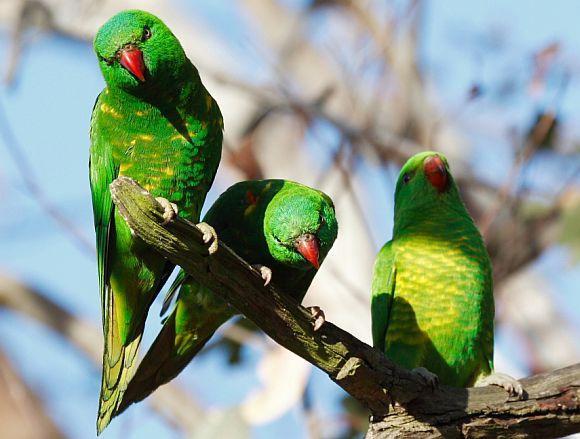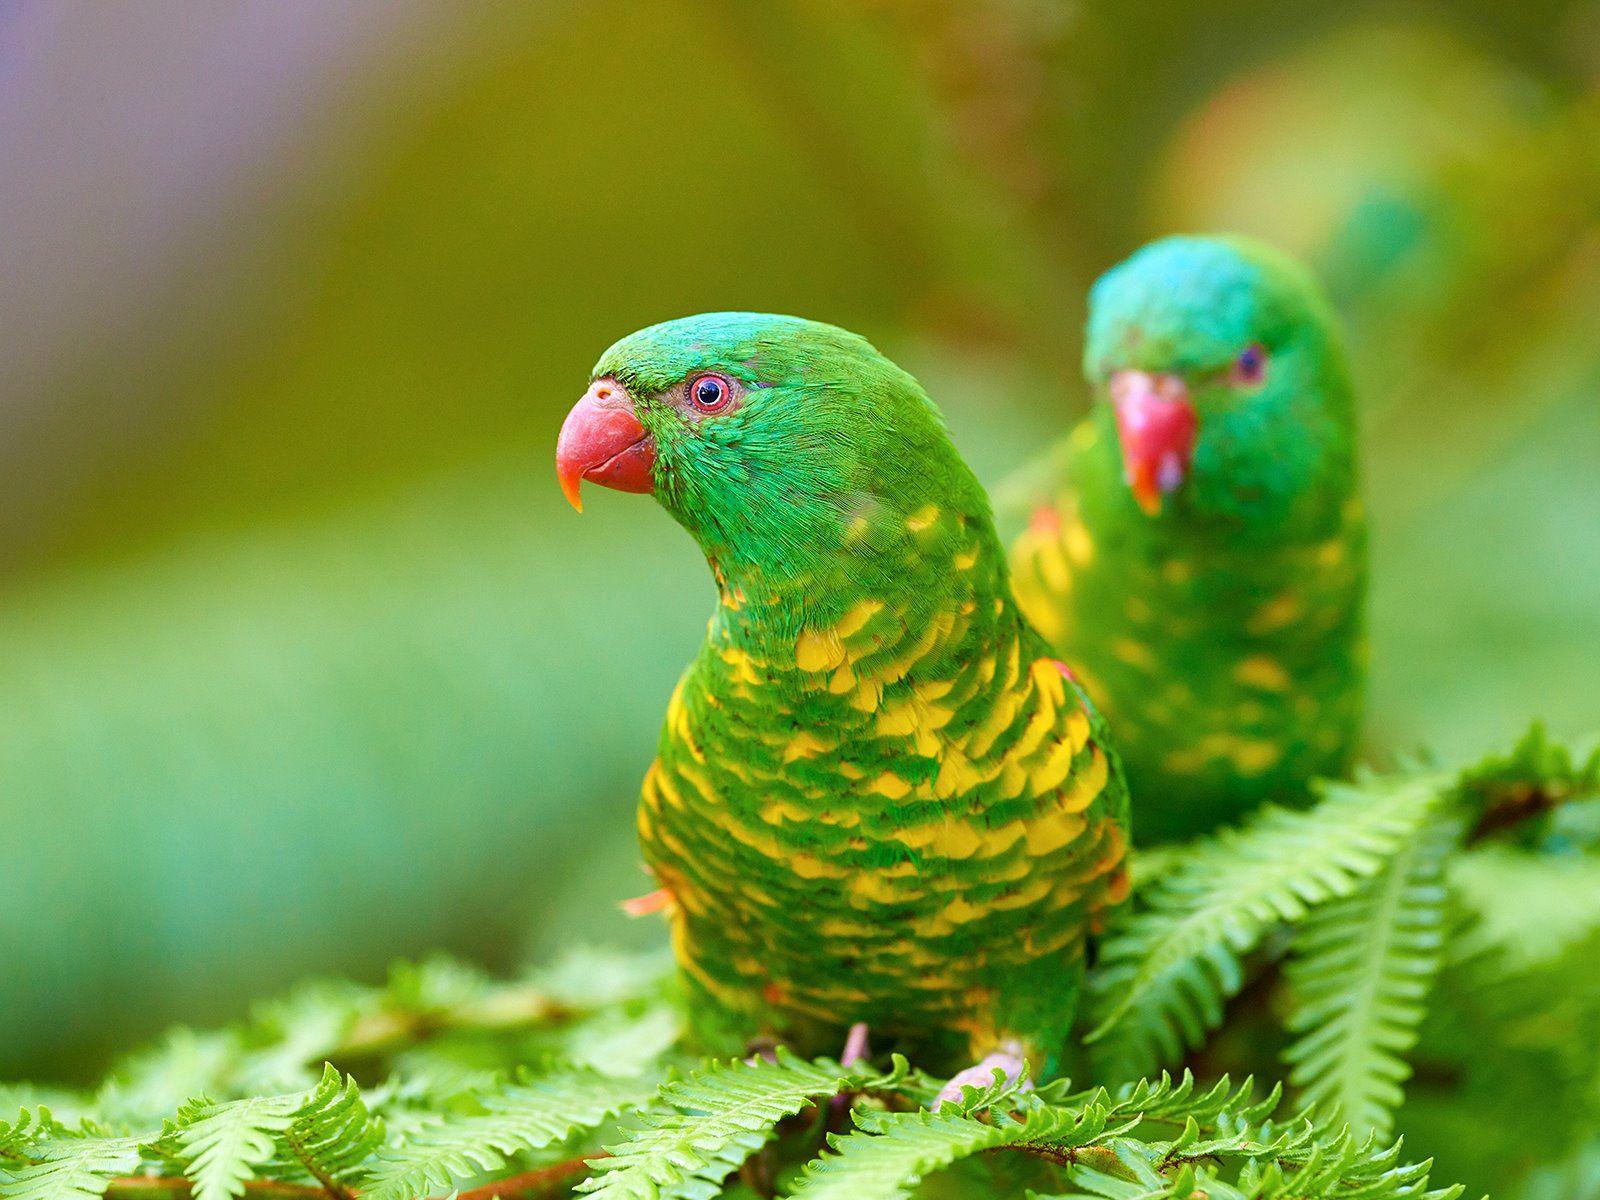The first image is the image on the left, the second image is the image on the right. Given the left and right images, does the statement "All parrots have green body feathers and red beaks." hold true? Answer yes or no. Yes. The first image is the image on the left, the second image is the image on the right. Considering the images on both sides, is "There is exactly one bird in the iamge on the right" valid? Answer yes or no. No. 